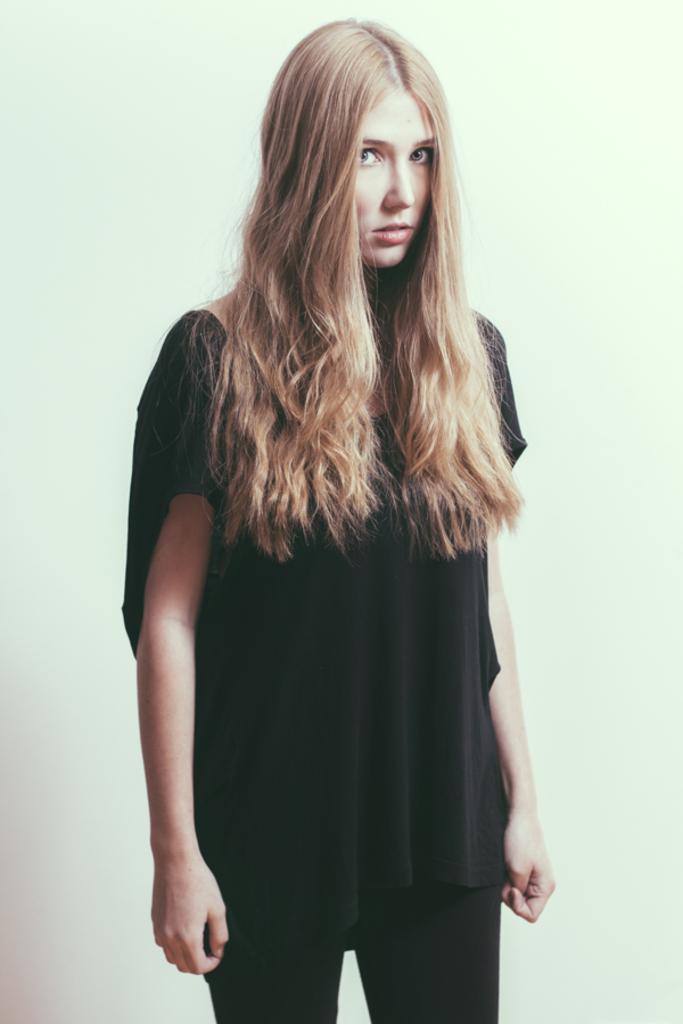Could you give a brief overview of what you see in this image? Here we can see a girl standing and in the background there is a wall. 